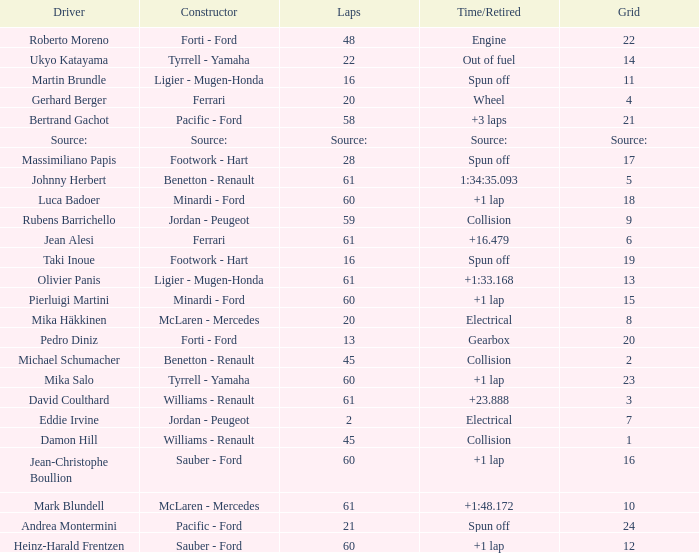How many laps does roberto moreno have? 48.0. 